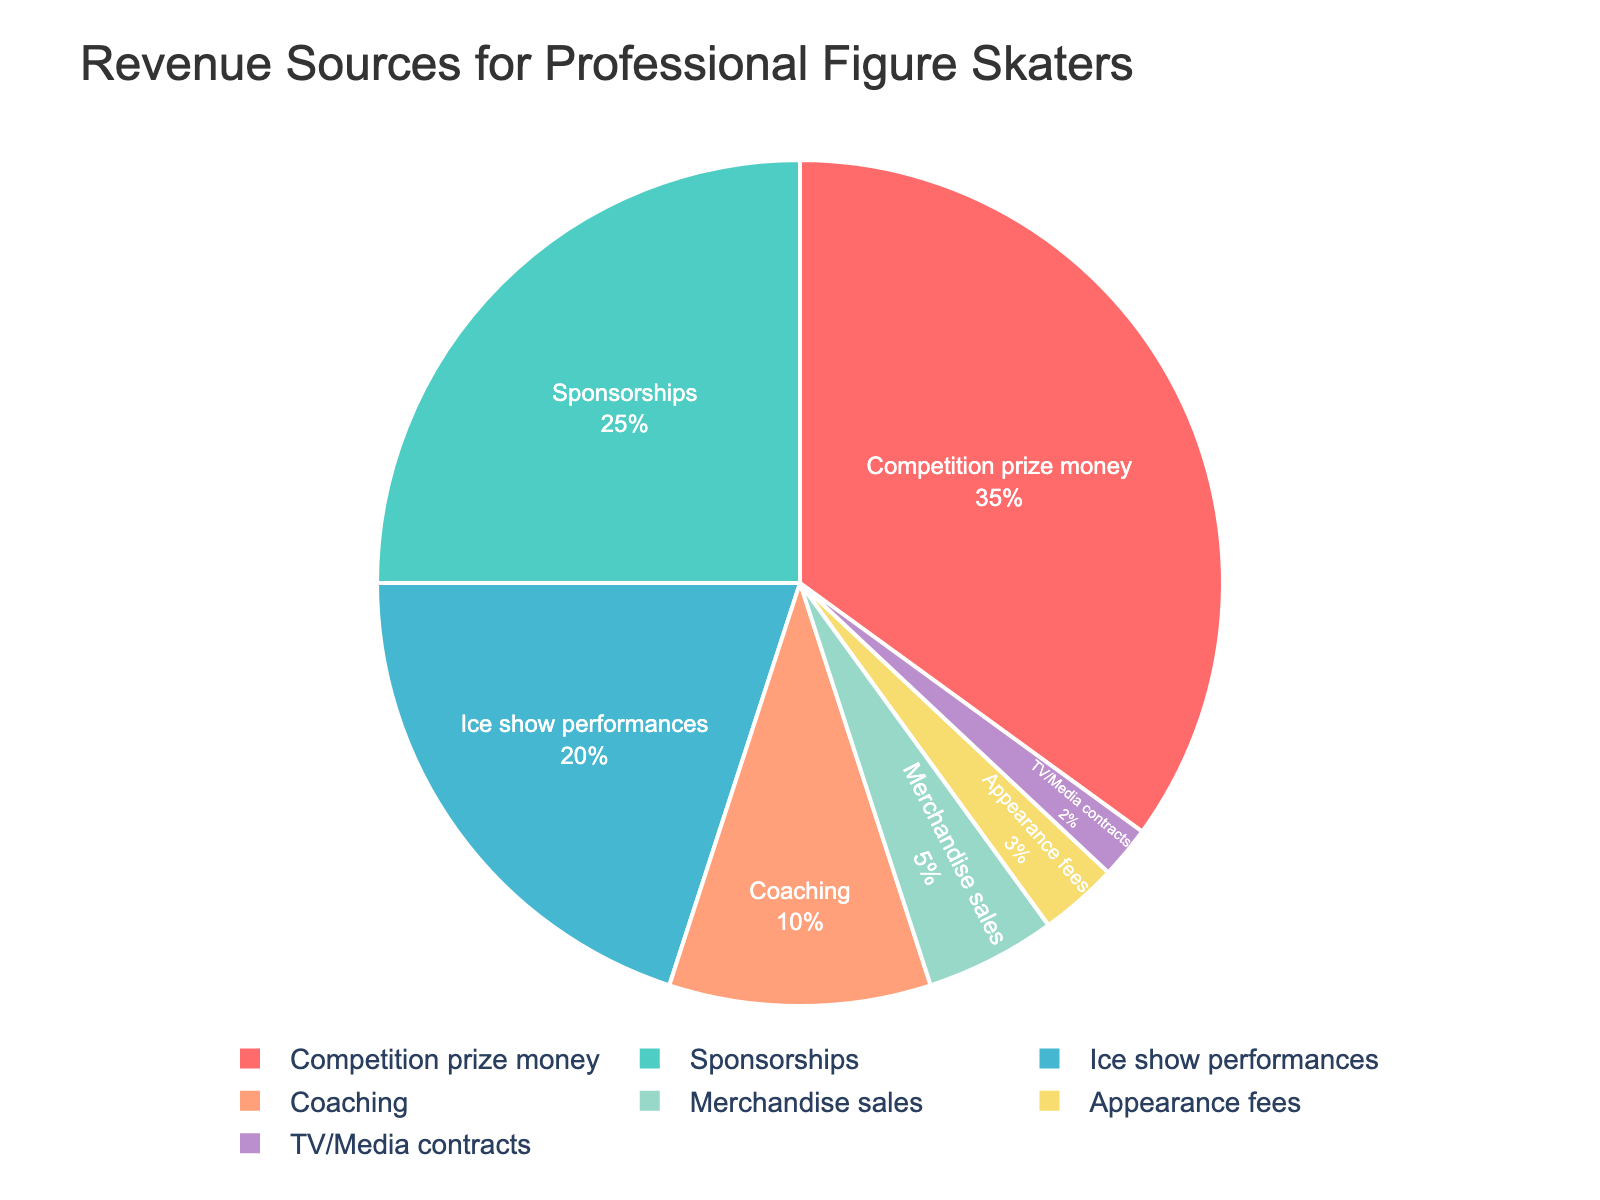What is the largest source of revenue for professional figure skaters? The largest segment in the pie chart represents "Competition prize money" with a percentage of 35%.
Answer: Competition prize money Which two revenue sources combined contribute the most to the total revenue? The two largest segments are "Competition prize money" and "Sponsorships," which are 35% and 25% respectively. Adding these together, 35% + 25% = 60%.
Answer: Competition prize money and Sponsorships What is the difference in percentage between Sponsorships and Ice show performances? The segment for Sponsorships is 25%, and the segment for Ice show performances is 20%. The difference is 25% - 20% = 5%.
Answer: 5% Which revenue category contributes the least to the total revenue, and what is its percentage? The smallest segment in the pie chart represents "TV/Media contracts" with a percentage of 2%.
Answer: TV/Media contracts, 2% Which categories have a combined contribution equal to or just over Ice show performances? The segment for Ice show performances is 20%. The next two largest segments that add up to 20% are "Coaching" and "Merchandise sales," which are 10% + 5% = 15%. Adding Appearance fees with 3%, we get 15% + 3% = 18%. To reach exactly 20%, we include TV/Media contracts with 2%: 18% + 2% = 20%.
Answer: Coaching, Merchandise sales, Appearance fees, TV/Media contracts If Coaching and Appearance fees switched places, what would be the combined contribution of Coaching and Ice show performances? Currently, Coaching is 10% and Appearance fees are 3%. If they switched places, Coaching would be 3%. Adding this to Ice show performances, which is 20%, we get 3% + 20% = 23%.
Answer: 23% How does the contribution of Merchandise sales compare to that of Coaching? The segment for Merchandise sales is 5%, and the segment for Coaching is 10%. Merchandise sales contribute less to the total revenue than Coaching by 10% - 5% = 5%.
Answer: Merchandise sales contribute 5% less than Coaching Which two categories together contribute less than sponsorships, and what is their combined percentage? The segment for Sponsorships is 25%. The two segments that together are less than Sponsorships are "Coaching" and "Merchandise sales," which are 10% + 5% = 15%.
Answer: Coaching and Merchandise sales, 15% What color is used to represent Ice show performances in the pie chart? The visual attribute representing Ice show performances is colored light orange (#FFA07A) in the pie chart.
Answer: Light orange What is the sum of percentages for the three smallest revenue sources? The three smallest segments are TV/Media contracts (2%), Appearance fees (3%), and Merchandise sales (5%). Summing these up, 2% + 3% + 5% = 10%.
Answer: 10% 